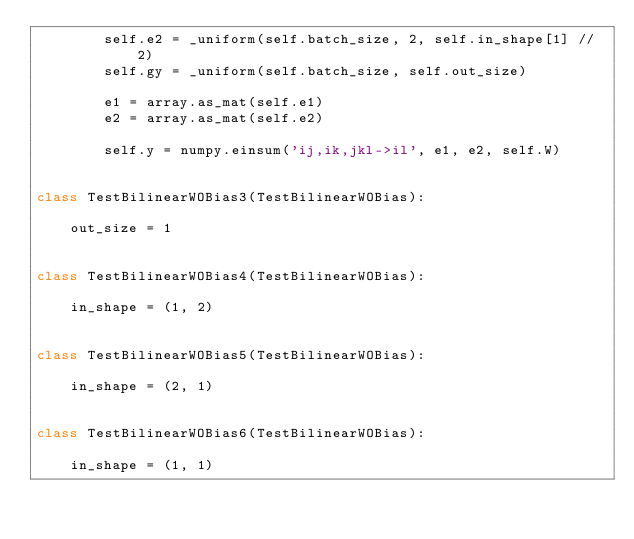Convert code to text. <code><loc_0><loc_0><loc_500><loc_500><_Python_>        self.e2 = _uniform(self.batch_size, 2, self.in_shape[1] // 2)
        self.gy = _uniform(self.batch_size, self.out_size)

        e1 = array.as_mat(self.e1)
        e2 = array.as_mat(self.e2)

        self.y = numpy.einsum('ij,ik,jkl->il', e1, e2, self.W)


class TestBilinearWOBias3(TestBilinearWOBias):

    out_size = 1


class TestBilinearWOBias4(TestBilinearWOBias):

    in_shape = (1, 2)


class TestBilinearWOBias5(TestBilinearWOBias):

    in_shape = (2, 1)


class TestBilinearWOBias6(TestBilinearWOBias):

    in_shape = (1, 1)

</code> 